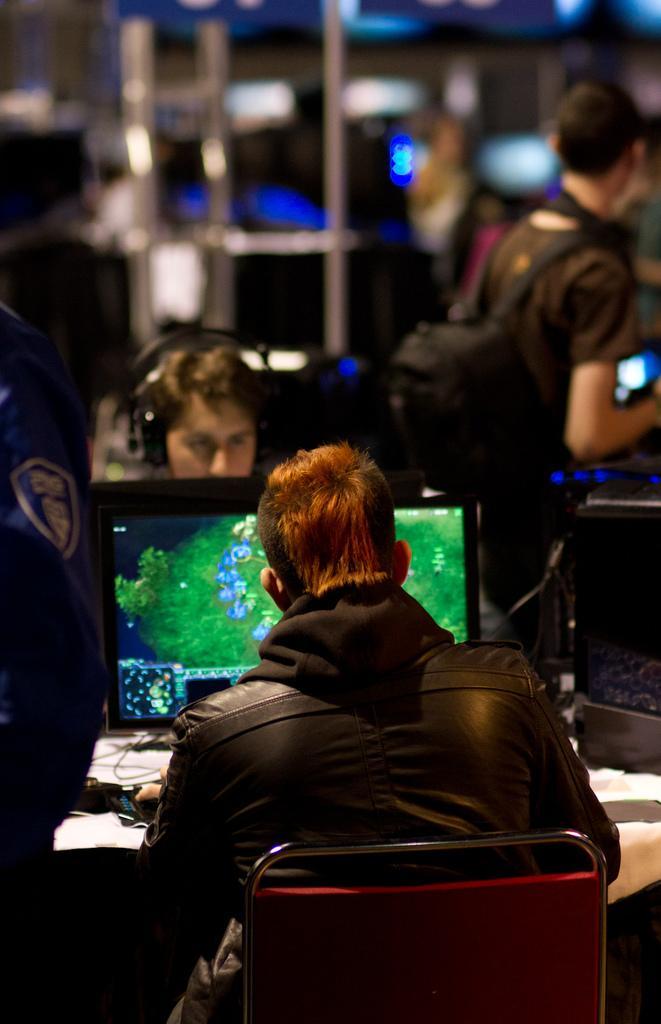Please provide a concise description of this image. In this picture I see 2 persons who are sitting in front and I see a monitor and in the background I see that it is totally blurred and I see a person on the right side who is standing. 